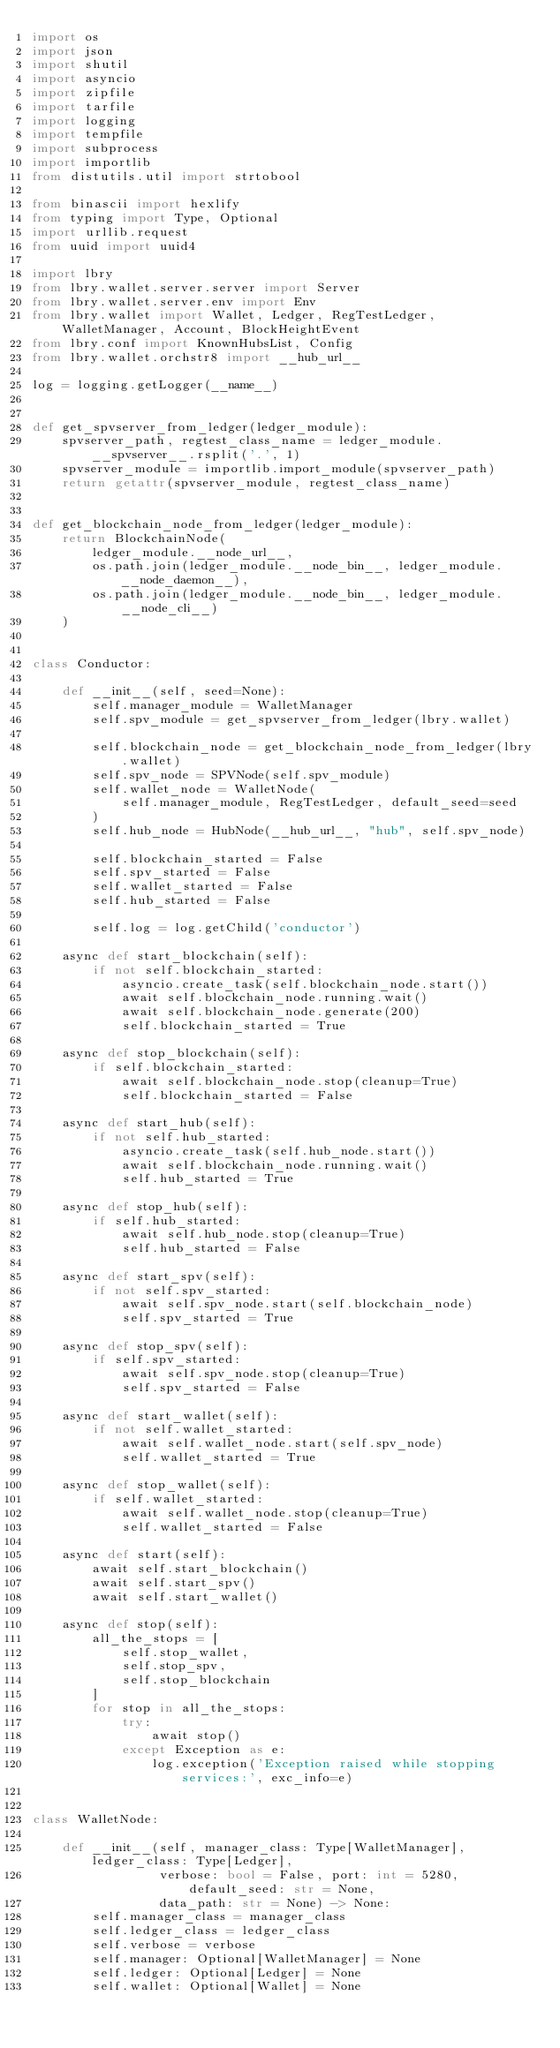<code> <loc_0><loc_0><loc_500><loc_500><_Python_>import os
import json
import shutil
import asyncio
import zipfile
import tarfile
import logging
import tempfile
import subprocess
import importlib
from distutils.util import strtobool

from binascii import hexlify
from typing import Type, Optional
import urllib.request
from uuid import uuid4

import lbry
from lbry.wallet.server.server import Server
from lbry.wallet.server.env import Env
from lbry.wallet import Wallet, Ledger, RegTestLedger, WalletManager, Account, BlockHeightEvent
from lbry.conf import KnownHubsList, Config
from lbry.wallet.orchstr8 import __hub_url__

log = logging.getLogger(__name__)


def get_spvserver_from_ledger(ledger_module):
    spvserver_path, regtest_class_name = ledger_module.__spvserver__.rsplit('.', 1)
    spvserver_module = importlib.import_module(spvserver_path)
    return getattr(spvserver_module, regtest_class_name)


def get_blockchain_node_from_ledger(ledger_module):
    return BlockchainNode(
        ledger_module.__node_url__,
        os.path.join(ledger_module.__node_bin__, ledger_module.__node_daemon__),
        os.path.join(ledger_module.__node_bin__, ledger_module.__node_cli__)
    )


class Conductor:

    def __init__(self, seed=None):
        self.manager_module = WalletManager
        self.spv_module = get_spvserver_from_ledger(lbry.wallet)

        self.blockchain_node = get_blockchain_node_from_ledger(lbry.wallet)
        self.spv_node = SPVNode(self.spv_module)
        self.wallet_node = WalletNode(
            self.manager_module, RegTestLedger, default_seed=seed
        )
        self.hub_node = HubNode(__hub_url__, "hub", self.spv_node)

        self.blockchain_started = False
        self.spv_started = False
        self.wallet_started = False
        self.hub_started = False

        self.log = log.getChild('conductor')

    async def start_blockchain(self):
        if not self.blockchain_started:
            asyncio.create_task(self.blockchain_node.start())
            await self.blockchain_node.running.wait()
            await self.blockchain_node.generate(200)
            self.blockchain_started = True

    async def stop_blockchain(self):
        if self.blockchain_started:
            await self.blockchain_node.stop(cleanup=True)
            self.blockchain_started = False

    async def start_hub(self):
        if not self.hub_started:
            asyncio.create_task(self.hub_node.start())
            await self.blockchain_node.running.wait()
            self.hub_started = True

    async def stop_hub(self):
        if self.hub_started:
            await self.hub_node.stop(cleanup=True)
            self.hub_started = False

    async def start_spv(self):
        if not self.spv_started:
            await self.spv_node.start(self.blockchain_node)
            self.spv_started = True

    async def stop_spv(self):
        if self.spv_started:
            await self.spv_node.stop(cleanup=True)
            self.spv_started = False

    async def start_wallet(self):
        if not self.wallet_started:
            await self.wallet_node.start(self.spv_node)
            self.wallet_started = True

    async def stop_wallet(self):
        if self.wallet_started:
            await self.wallet_node.stop(cleanup=True)
            self.wallet_started = False

    async def start(self):
        await self.start_blockchain()
        await self.start_spv()
        await self.start_wallet()

    async def stop(self):
        all_the_stops = [
            self.stop_wallet,
            self.stop_spv,
            self.stop_blockchain
        ]
        for stop in all_the_stops:
            try:
                await stop()
            except Exception as e:
                log.exception('Exception raised while stopping services:', exc_info=e)


class WalletNode:

    def __init__(self, manager_class: Type[WalletManager], ledger_class: Type[Ledger],
                 verbose: bool = False, port: int = 5280, default_seed: str = None,
                 data_path: str = None) -> None:
        self.manager_class = manager_class
        self.ledger_class = ledger_class
        self.verbose = verbose
        self.manager: Optional[WalletManager] = None
        self.ledger: Optional[Ledger] = None
        self.wallet: Optional[Wallet] = None</code> 